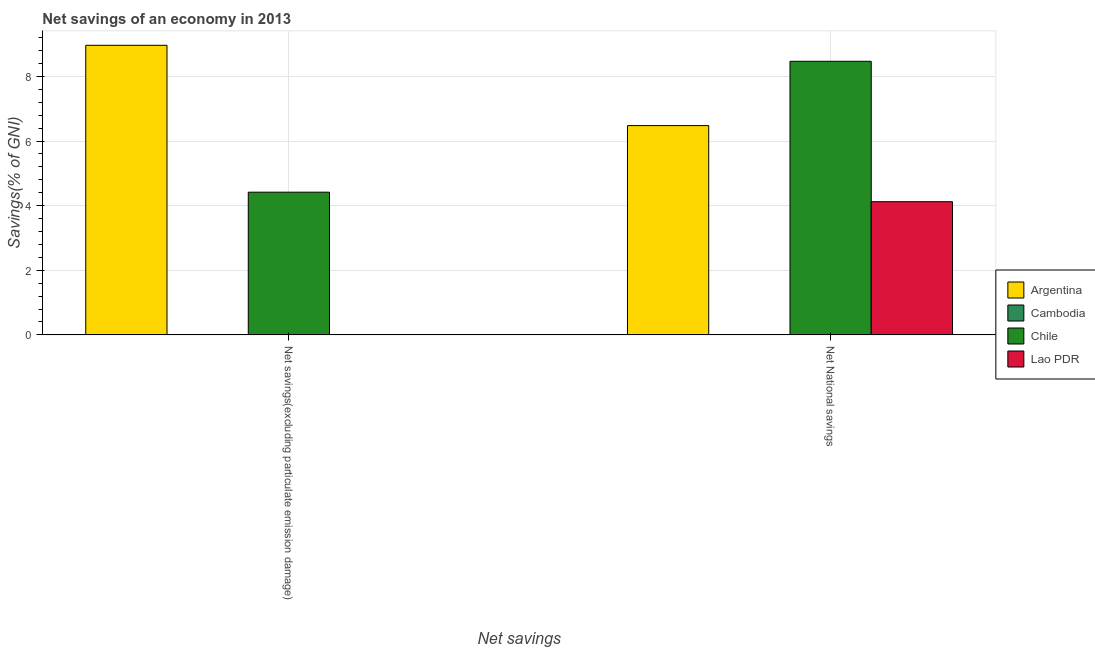How many different coloured bars are there?
Offer a terse response. 3. How many groups of bars are there?
Offer a very short reply. 2. Are the number of bars per tick equal to the number of legend labels?
Offer a terse response. No. Are the number of bars on each tick of the X-axis equal?
Offer a terse response. No. How many bars are there on the 1st tick from the left?
Provide a short and direct response. 2. What is the label of the 1st group of bars from the left?
Your response must be concise. Net savings(excluding particulate emission damage). What is the net national savings in Chile?
Give a very brief answer. 8.47. Across all countries, what is the maximum net national savings?
Give a very brief answer. 8.47. What is the total net savings(excluding particulate emission damage) in the graph?
Make the answer very short. 13.38. What is the difference between the net national savings in Argentina and that in Lao PDR?
Make the answer very short. 2.36. What is the difference between the net national savings in Cambodia and the net savings(excluding particulate emission damage) in Chile?
Your answer should be very brief. -4.42. What is the average net savings(excluding particulate emission damage) per country?
Offer a very short reply. 3.35. What is the difference between the net savings(excluding particulate emission damage) and net national savings in Argentina?
Offer a very short reply. 2.49. What is the ratio of the net savings(excluding particulate emission damage) in Argentina to that in Chile?
Your answer should be very brief. 2.03. How many countries are there in the graph?
Your answer should be compact. 4. What is the difference between two consecutive major ticks on the Y-axis?
Offer a terse response. 2. How are the legend labels stacked?
Keep it short and to the point. Vertical. What is the title of the graph?
Give a very brief answer. Net savings of an economy in 2013. Does "Andorra" appear as one of the legend labels in the graph?
Provide a short and direct response. No. What is the label or title of the X-axis?
Your response must be concise. Net savings. What is the label or title of the Y-axis?
Keep it short and to the point. Savings(% of GNI). What is the Savings(% of GNI) of Argentina in Net savings(excluding particulate emission damage)?
Offer a terse response. 8.96. What is the Savings(% of GNI) of Chile in Net savings(excluding particulate emission damage)?
Provide a short and direct response. 4.42. What is the Savings(% of GNI) of Lao PDR in Net savings(excluding particulate emission damage)?
Provide a short and direct response. 0. What is the Savings(% of GNI) of Argentina in Net National savings?
Your answer should be compact. 6.48. What is the Savings(% of GNI) in Chile in Net National savings?
Provide a succinct answer. 8.47. What is the Savings(% of GNI) in Lao PDR in Net National savings?
Provide a succinct answer. 4.12. Across all Net savings, what is the maximum Savings(% of GNI) in Argentina?
Offer a terse response. 8.96. Across all Net savings, what is the maximum Savings(% of GNI) of Chile?
Provide a short and direct response. 8.47. Across all Net savings, what is the maximum Savings(% of GNI) in Lao PDR?
Offer a very short reply. 4.12. Across all Net savings, what is the minimum Savings(% of GNI) in Argentina?
Provide a succinct answer. 6.48. Across all Net savings, what is the minimum Savings(% of GNI) of Chile?
Your answer should be compact. 4.42. What is the total Savings(% of GNI) in Argentina in the graph?
Offer a terse response. 15.44. What is the total Savings(% of GNI) of Cambodia in the graph?
Provide a short and direct response. 0. What is the total Savings(% of GNI) of Chile in the graph?
Ensure brevity in your answer.  12.89. What is the total Savings(% of GNI) in Lao PDR in the graph?
Offer a terse response. 4.12. What is the difference between the Savings(% of GNI) in Argentina in Net savings(excluding particulate emission damage) and that in Net National savings?
Your answer should be compact. 2.49. What is the difference between the Savings(% of GNI) of Chile in Net savings(excluding particulate emission damage) and that in Net National savings?
Make the answer very short. -4.05. What is the difference between the Savings(% of GNI) in Argentina in Net savings(excluding particulate emission damage) and the Savings(% of GNI) in Chile in Net National savings?
Provide a short and direct response. 0.49. What is the difference between the Savings(% of GNI) in Argentina in Net savings(excluding particulate emission damage) and the Savings(% of GNI) in Lao PDR in Net National savings?
Offer a terse response. 4.84. What is the difference between the Savings(% of GNI) in Chile in Net savings(excluding particulate emission damage) and the Savings(% of GNI) in Lao PDR in Net National savings?
Your answer should be compact. 0.29. What is the average Savings(% of GNI) in Argentina per Net savings?
Offer a terse response. 7.72. What is the average Savings(% of GNI) of Cambodia per Net savings?
Keep it short and to the point. 0. What is the average Savings(% of GNI) of Chile per Net savings?
Ensure brevity in your answer.  6.44. What is the average Savings(% of GNI) in Lao PDR per Net savings?
Provide a succinct answer. 2.06. What is the difference between the Savings(% of GNI) of Argentina and Savings(% of GNI) of Chile in Net savings(excluding particulate emission damage)?
Your answer should be very brief. 4.55. What is the difference between the Savings(% of GNI) of Argentina and Savings(% of GNI) of Chile in Net National savings?
Give a very brief answer. -1.99. What is the difference between the Savings(% of GNI) in Argentina and Savings(% of GNI) in Lao PDR in Net National savings?
Make the answer very short. 2.36. What is the difference between the Savings(% of GNI) in Chile and Savings(% of GNI) in Lao PDR in Net National savings?
Give a very brief answer. 4.35. What is the ratio of the Savings(% of GNI) in Argentina in Net savings(excluding particulate emission damage) to that in Net National savings?
Offer a terse response. 1.38. What is the ratio of the Savings(% of GNI) in Chile in Net savings(excluding particulate emission damage) to that in Net National savings?
Ensure brevity in your answer.  0.52. What is the difference between the highest and the second highest Savings(% of GNI) of Argentina?
Your answer should be compact. 2.49. What is the difference between the highest and the second highest Savings(% of GNI) of Chile?
Give a very brief answer. 4.05. What is the difference between the highest and the lowest Savings(% of GNI) in Argentina?
Ensure brevity in your answer.  2.49. What is the difference between the highest and the lowest Savings(% of GNI) in Chile?
Your response must be concise. 4.05. What is the difference between the highest and the lowest Savings(% of GNI) of Lao PDR?
Your answer should be compact. 4.12. 